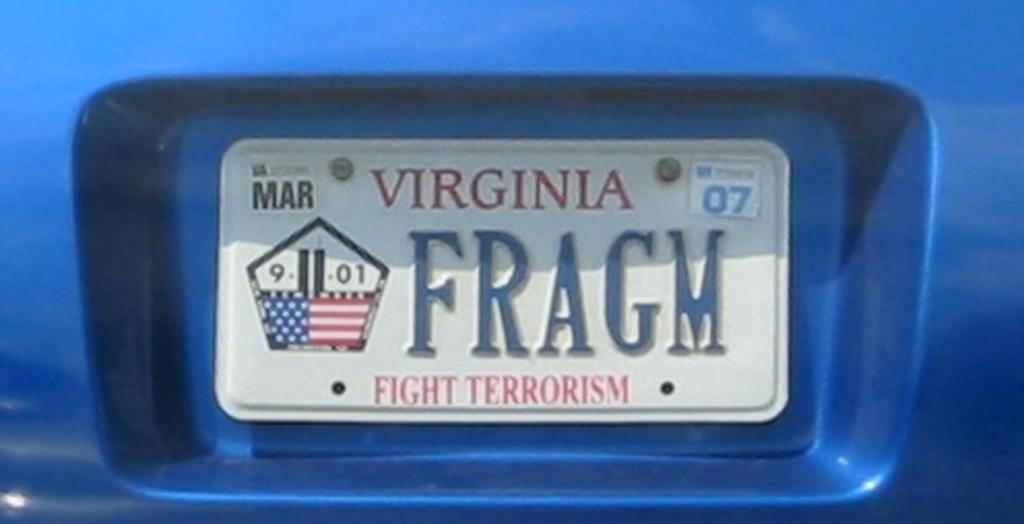<image>
Summarize the visual content of the image. Virginia license plate reading "FRAGM" and a 9/11/01 pentagon memorial plaque with the "11" being formed by the twin towers. 